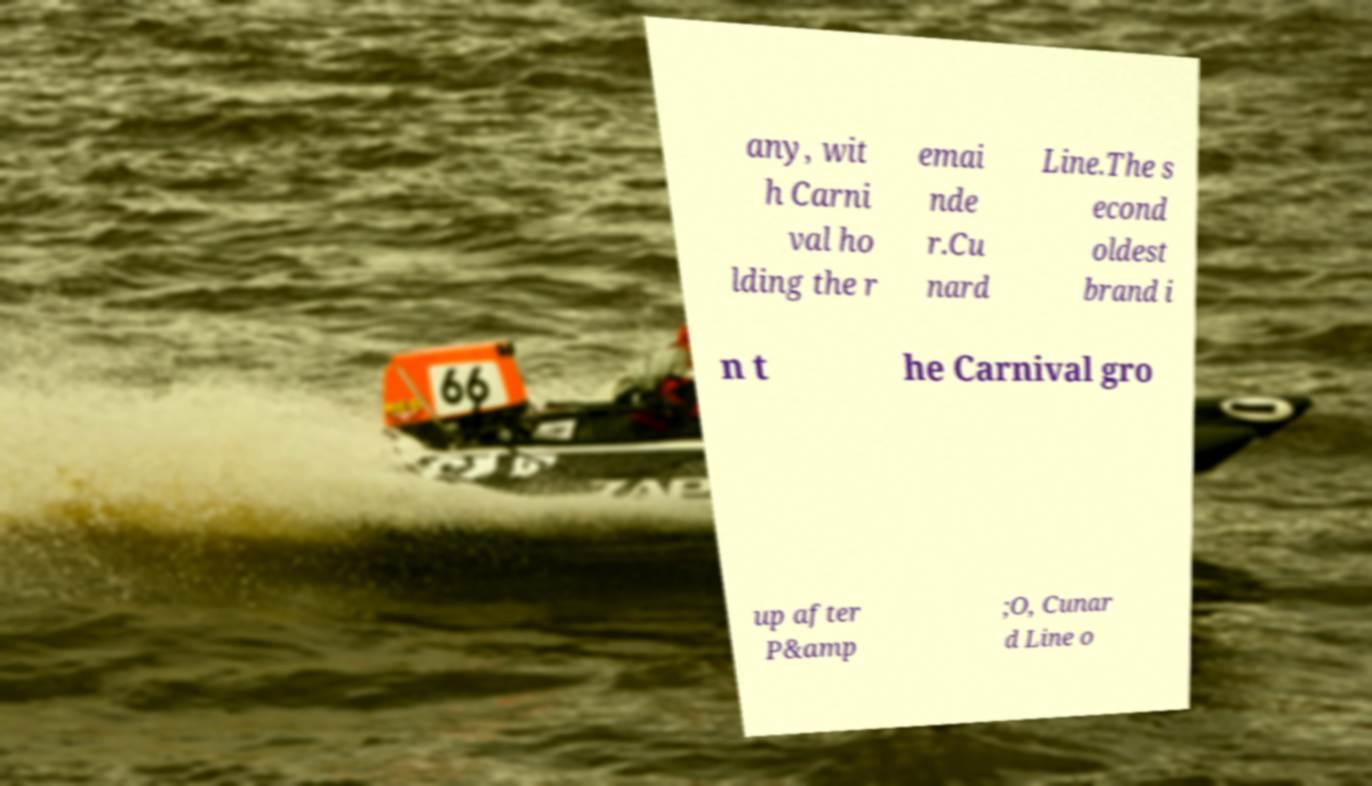Could you extract and type out the text from this image? any, wit h Carni val ho lding the r emai nde r.Cu nard Line.The s econd oldest brand i n t he Carnival gro up after P&amp ;O, Cunar d Line o 